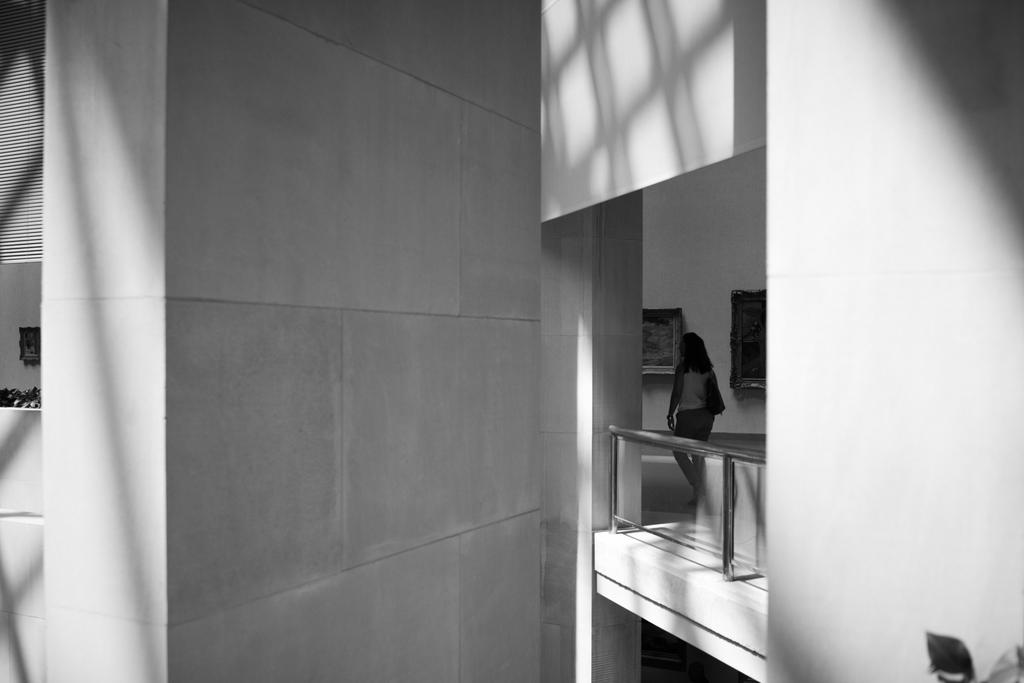What type of structures can be seen in the image? There are walls and frames in the image. What other architectural feature is present in the image? There is railing in the image. What natural elements can be seen in the image? There are leaves in the image. What is the woman in the image doing? The woman is carrying a bag in the image. What type of flesh can be seen in the image? There is no flesh visible in the image. The image contains walls, frames, railing, leaves, and a woman carrying a bag, but no flesh. 